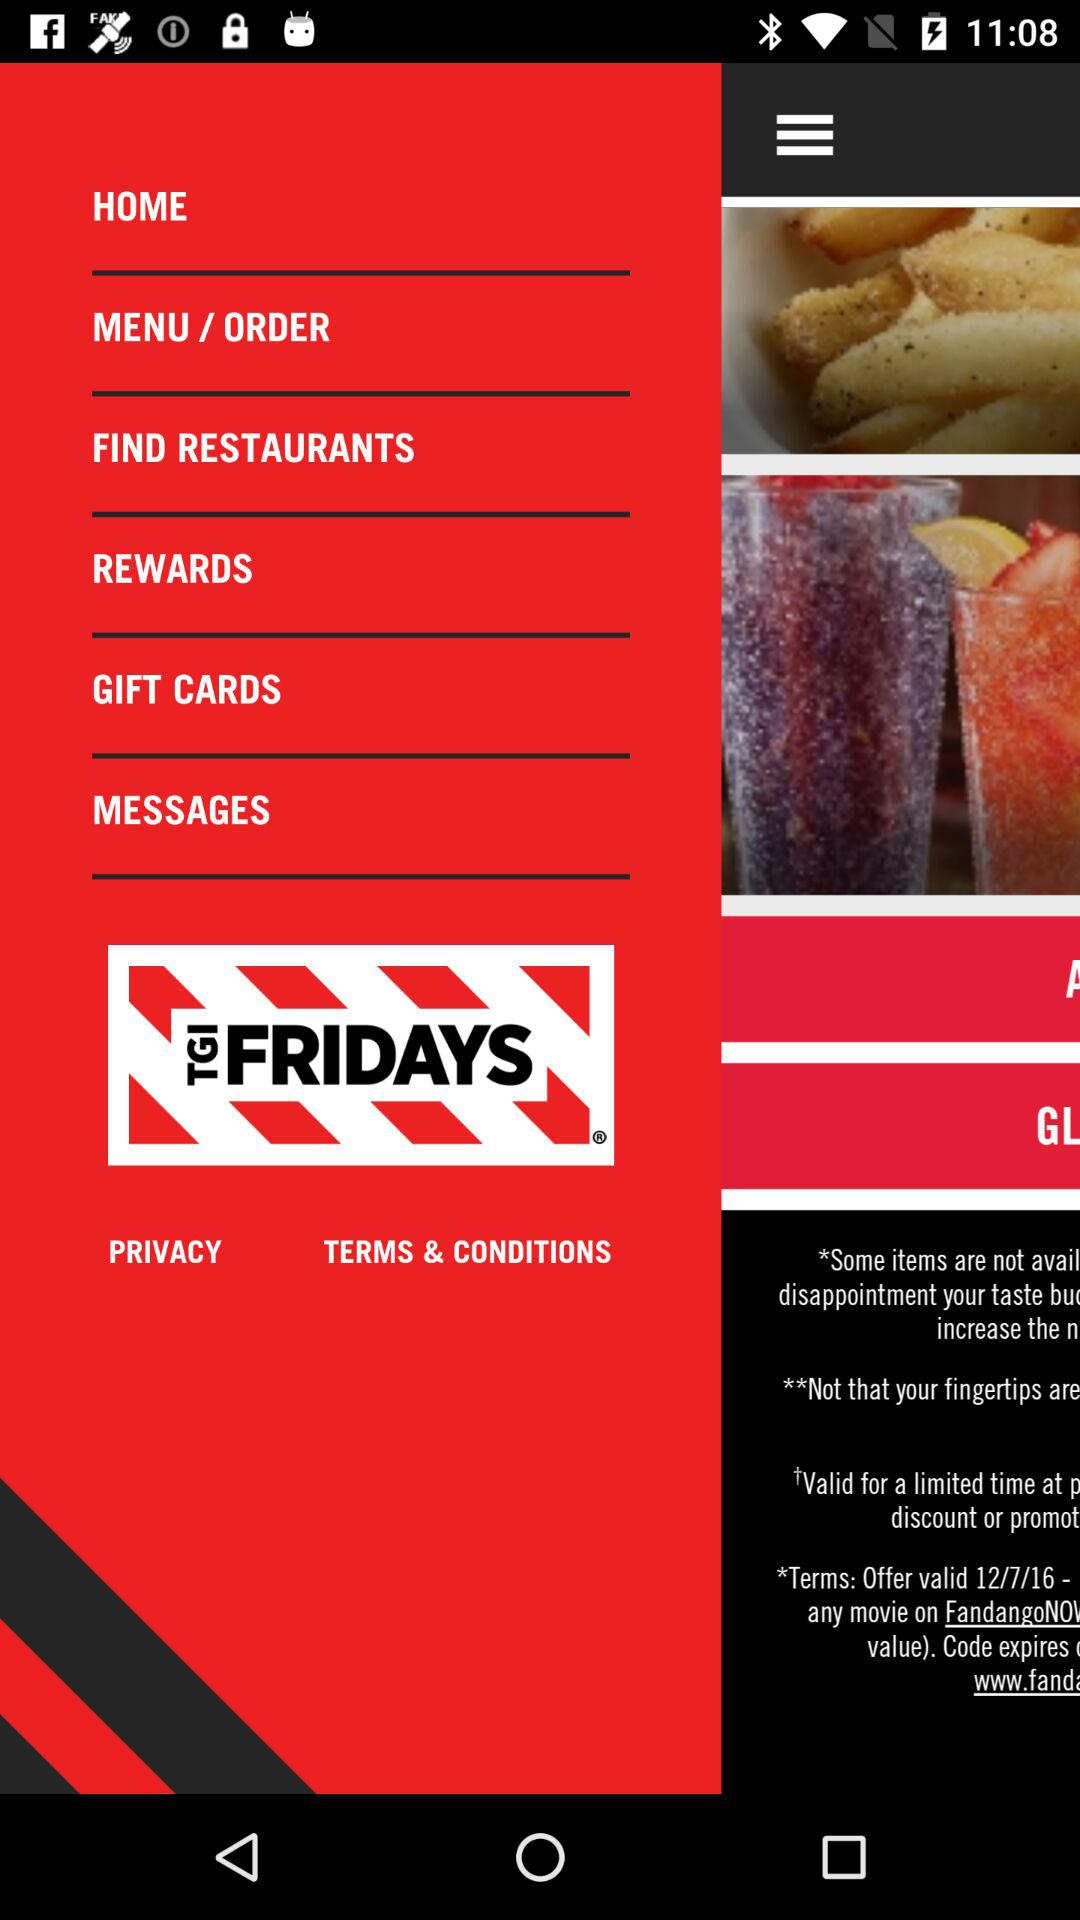What are the terms and conditions?
When the provided information is insufficient, respond with <no answer>. <no answer> 